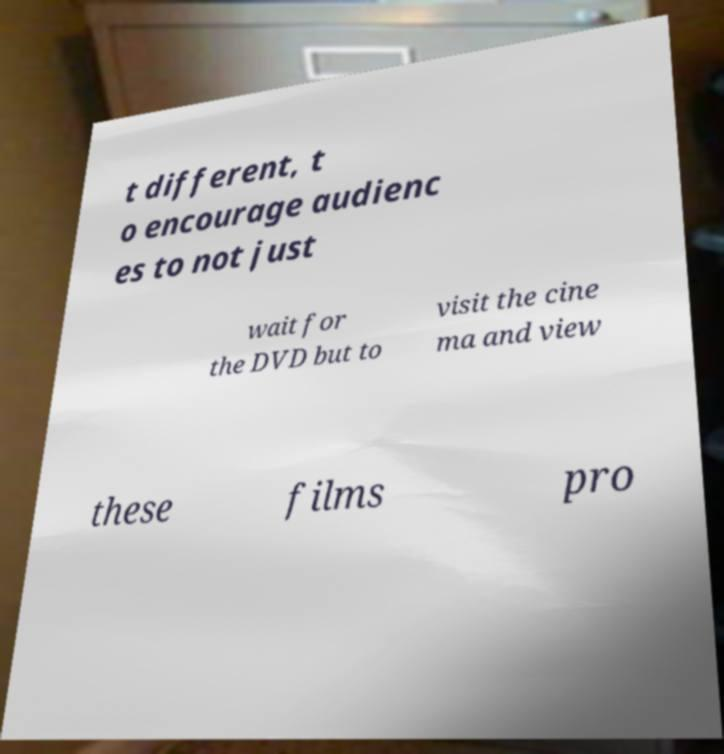There's text embedded in this image that I need extracted. Can you transcribe it verbatim? t different, t o encourage audienc es to not just wait for the DVD but to visit the cine ma and view these films pro 